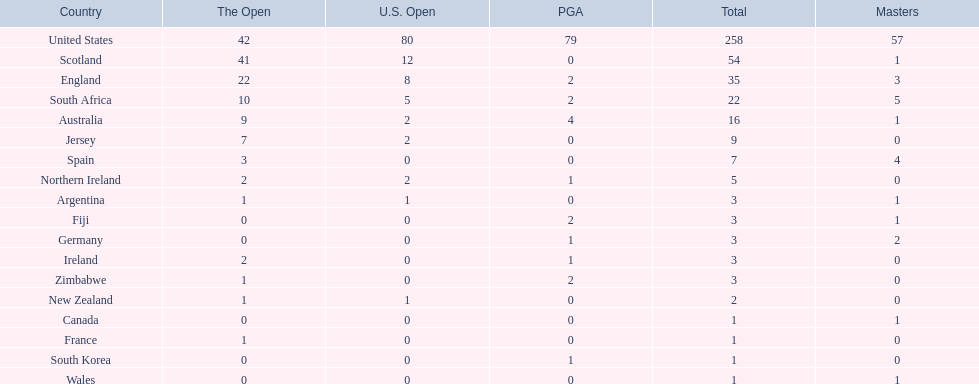What are all the countries? United States, Scotland, England, South Africa, Australia, Jersey, Spain, Northern Ireland, Argentina, Fiji, Germany, Ireland, Zimbabwe, New Zealand, Canada, France, South Korea, Wales. Which ones are located in africa? South Africa, Zimbabwe. Of those, which has the least champion golfers? Zimbabwe. 